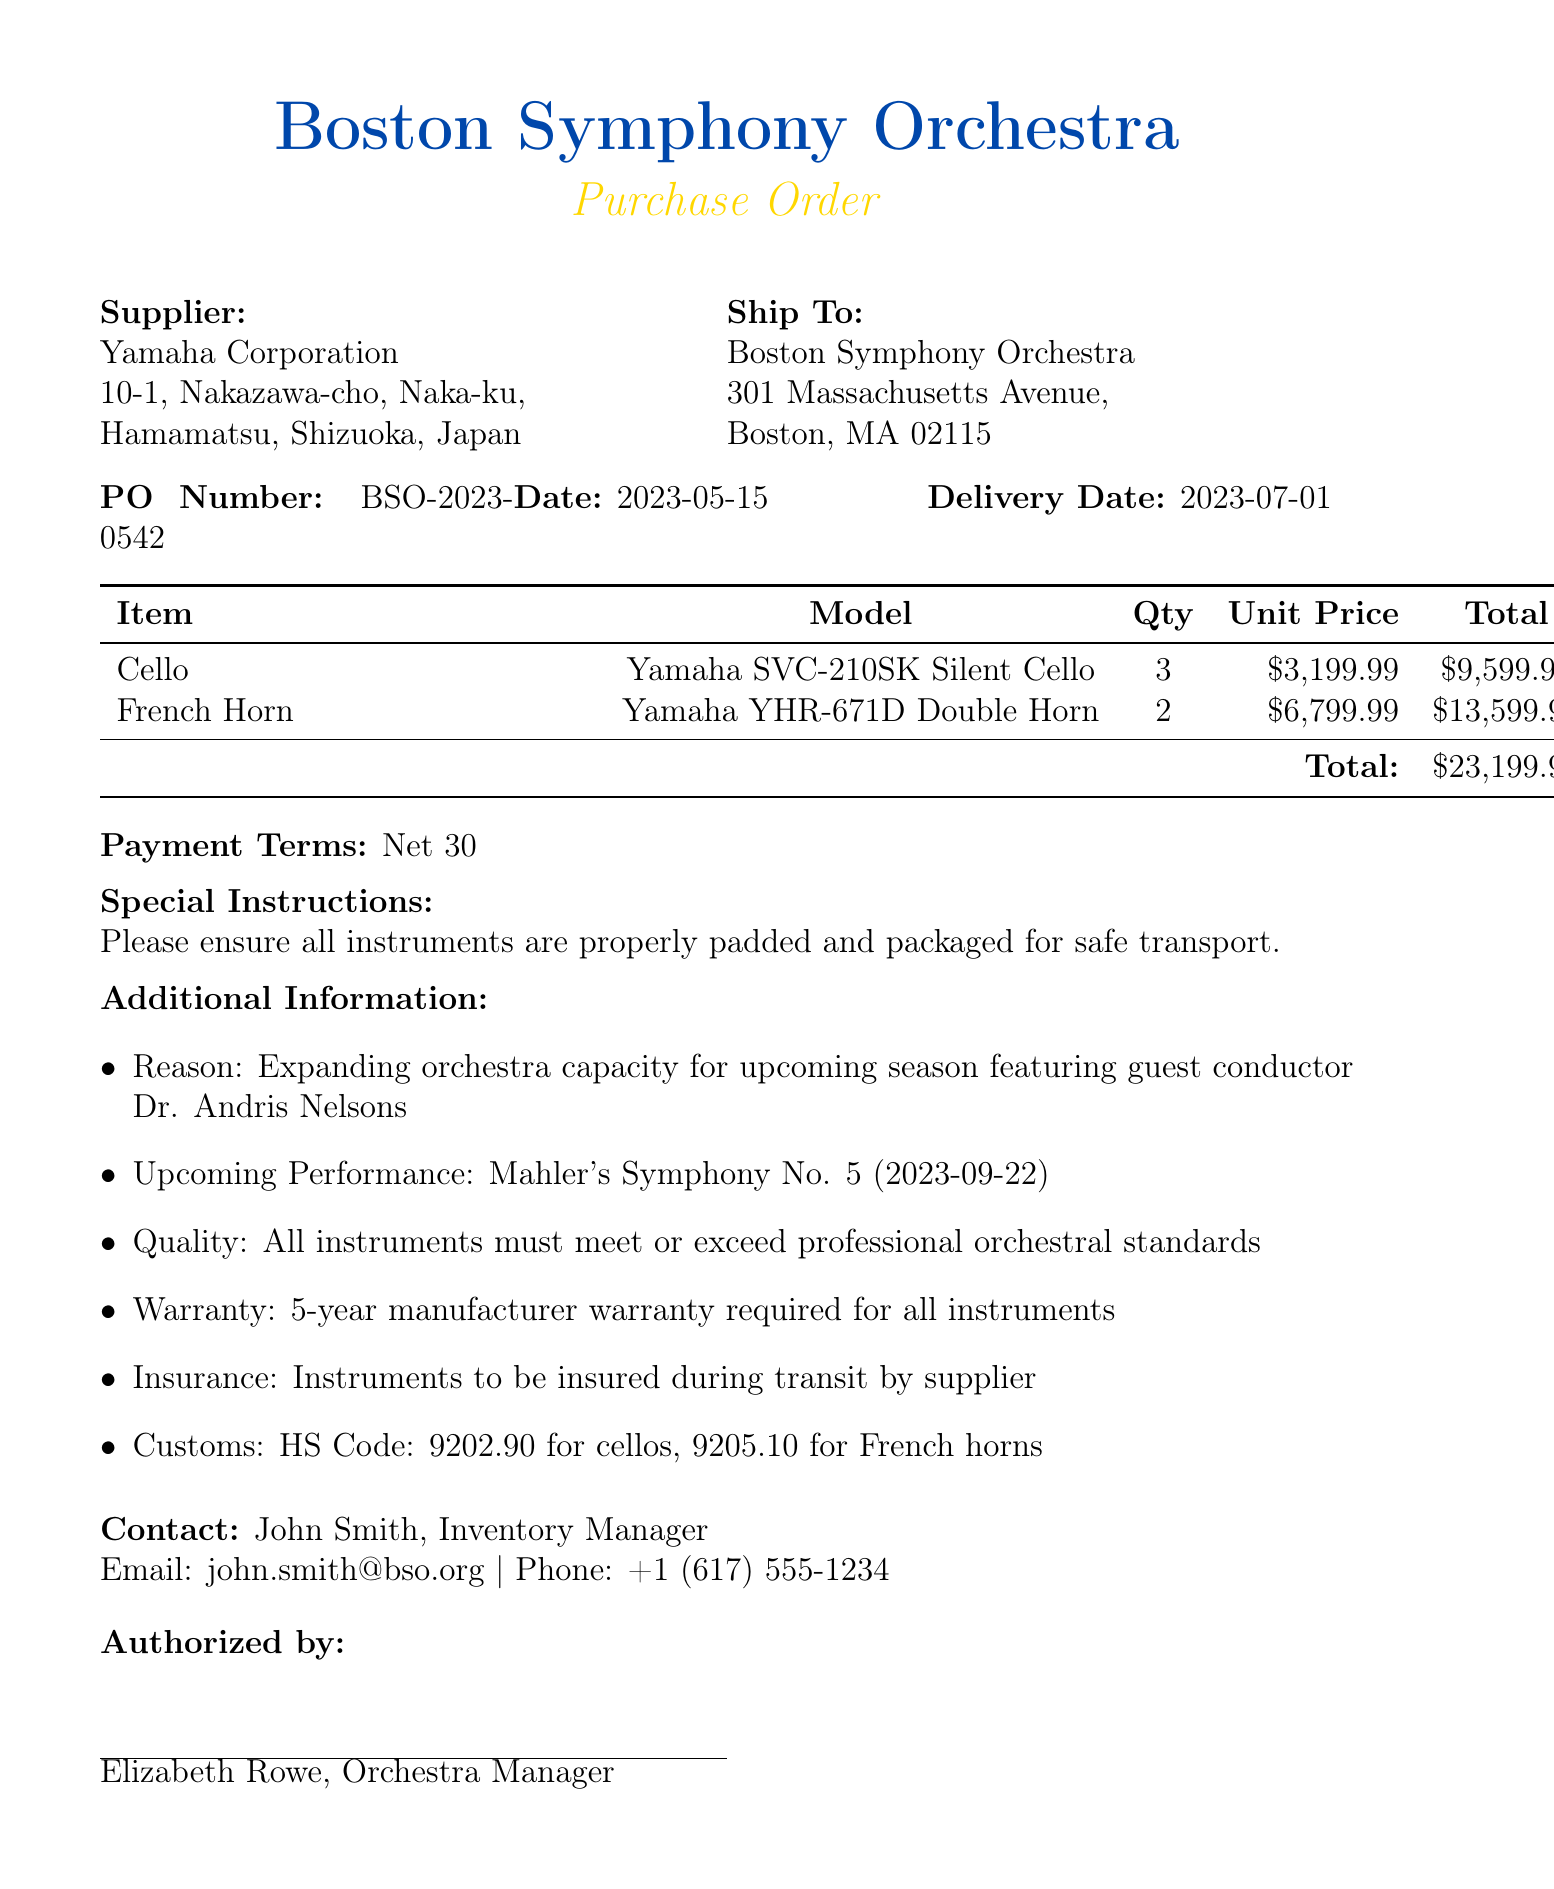What is the purchase order number? The purchase order number is specifically mentioned in the document as a unique identifier for the transaction.
Answer: BSO-2023-0542 Who is the supplier of the instruments? The document states the name of the company providing the instruments to the orchestra.
Answer: Yamaha Corporation What is the total amount for the purchase? The total amount is indicated at the end of the itemized list of instruments.
Answer: $23199.95 What is the delivery address? The delivery address is listed to specify where the ordered instruments should be sent.
Answer: 301 Massachusetts Avenue, Boston, MA 02115 What is the warranty duration required for the instruments? The warranty is mentioned in the document and specifies the length of protection for the instruments.
Answer: 5-year manufacturer warranty Why are the new instruments being purchased? The reason for the purchase is provided to explain the necessity behind the order, considering the upcoming events.
Answer: Expanding orchestra capacity for upcoming season featuring guest conductor Dr. Andris Nelsons What is the upcoming performance mentioned in the document? The document references a specific orchestral work scheduled for performance, which is relevant to the context of the instrument purchase.
Answer: Mahler's Symphony No. 5 How many cellos are being ordered? The quantity for each type of instrument is broken down in the table, specifying the exact number of cellos requested.
Answer: 3 What is the estimated delivery date of the instruments? The document indicates the expected timeframe for when the order will arrive, which helps in planning ahead.
Answer: 2023-07-01 